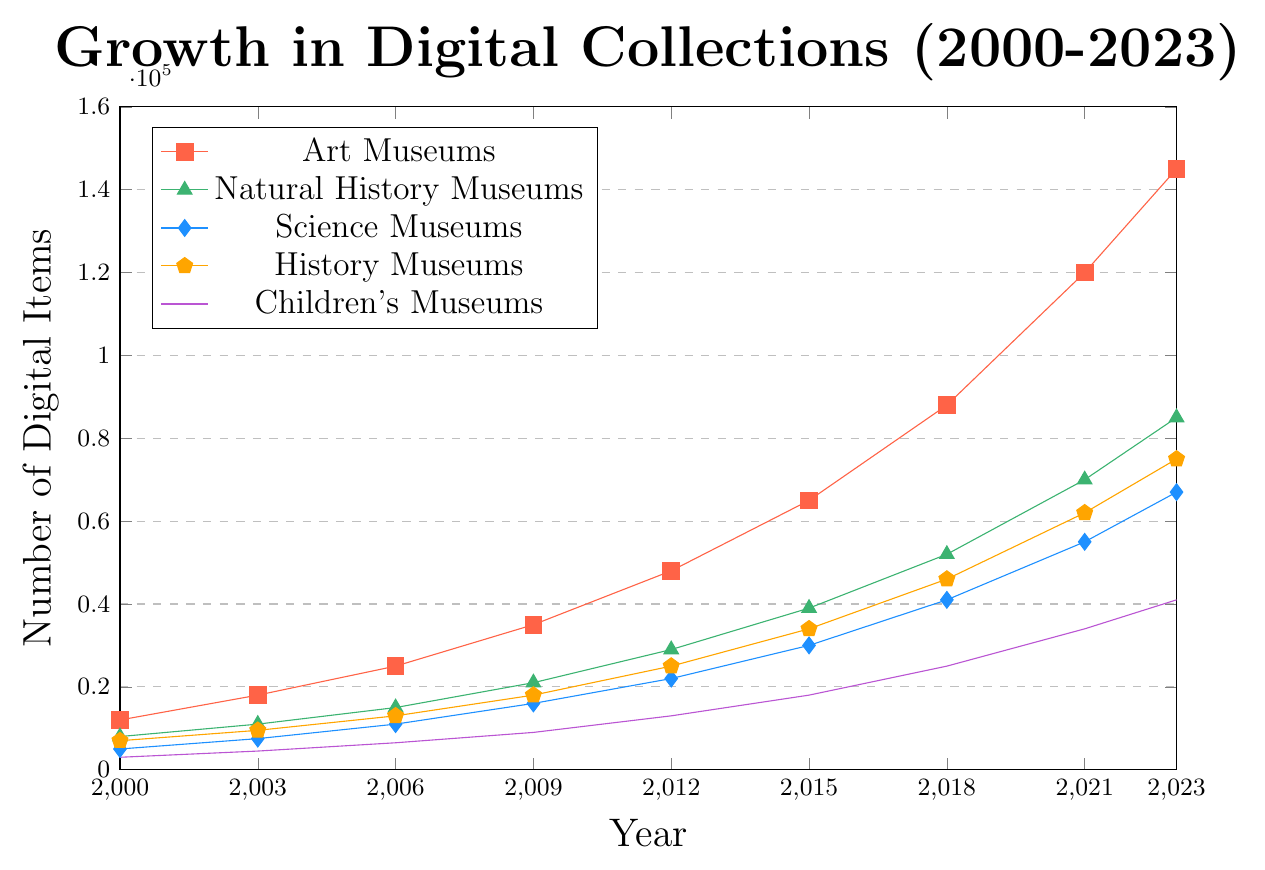What is the total number of digital items across all museum categories in 2000? To find the total number of digital items, we need to sum the values for all museum categories in the year 2000: 12000 (Art Museums) + 8000 (Natural History Museums) + 5000 (Science Museums) + 7000 (History Museums) + 3000 (Children's Museums). So, 12000 + 8000 + 5000 + 7000 + 3000 = 35000.
Answer: 35000 In which year did Natural History Museums surpass 50000 digital items? Looking at the data points for Natural History Museums, the number surpasses 50000 in the year 2018.
Answer: 2018 What is the average number of digital items for Science Museums over the entire period? Sum the data points for Science Museums and divide by the number of years: (5000 + 7500 + 11000 + 16000 + 22000 + 30000 + 41000 + 55000 + 67000) / 9. The sum is 254500, so the average is 254500 / 9 = 28277.78.
Answer: 28277.78 How much did the number of digital items for Children's Museums change from 2015 to 2021? To find the change, subtract the number of items in 2015 from that in 2021 for Children's Museums: 34000 - 18000. So, the change is 34000 - 18000 = 16000.
Answer: 16000 